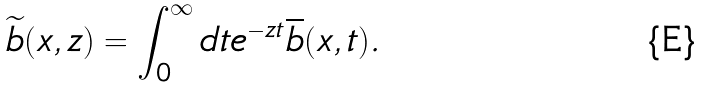Convert formula to latex. <formula><loc_0><loc_0><loc_500><loc_500>\widetilde { b } ( x , z ) = \int _ { 0 } ^ { \infty } d t e ^ { - z t } \overline { b } ( x , t ) .</formula> 